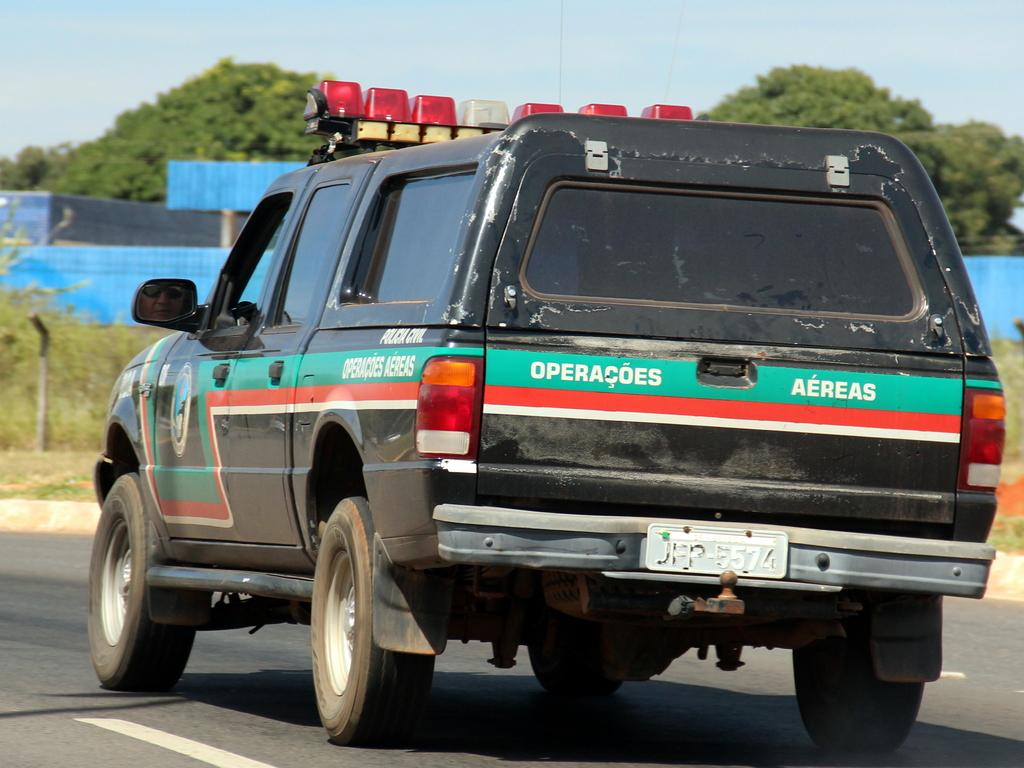What is the main subject of the image? There is a vehicle in the image. What is the vehicle located on or near? There is a road in the image. What other objects can be seen in the image? There is a pole, a shed in the background, and trees in the image. What part of the natural environment is visible in the image? The sky is visible in the image. What type of crime is being committed in the image? There is no indication of a crime being committed in the image. What shape is the discussion taking in the image? There is no discussion present in the image. 